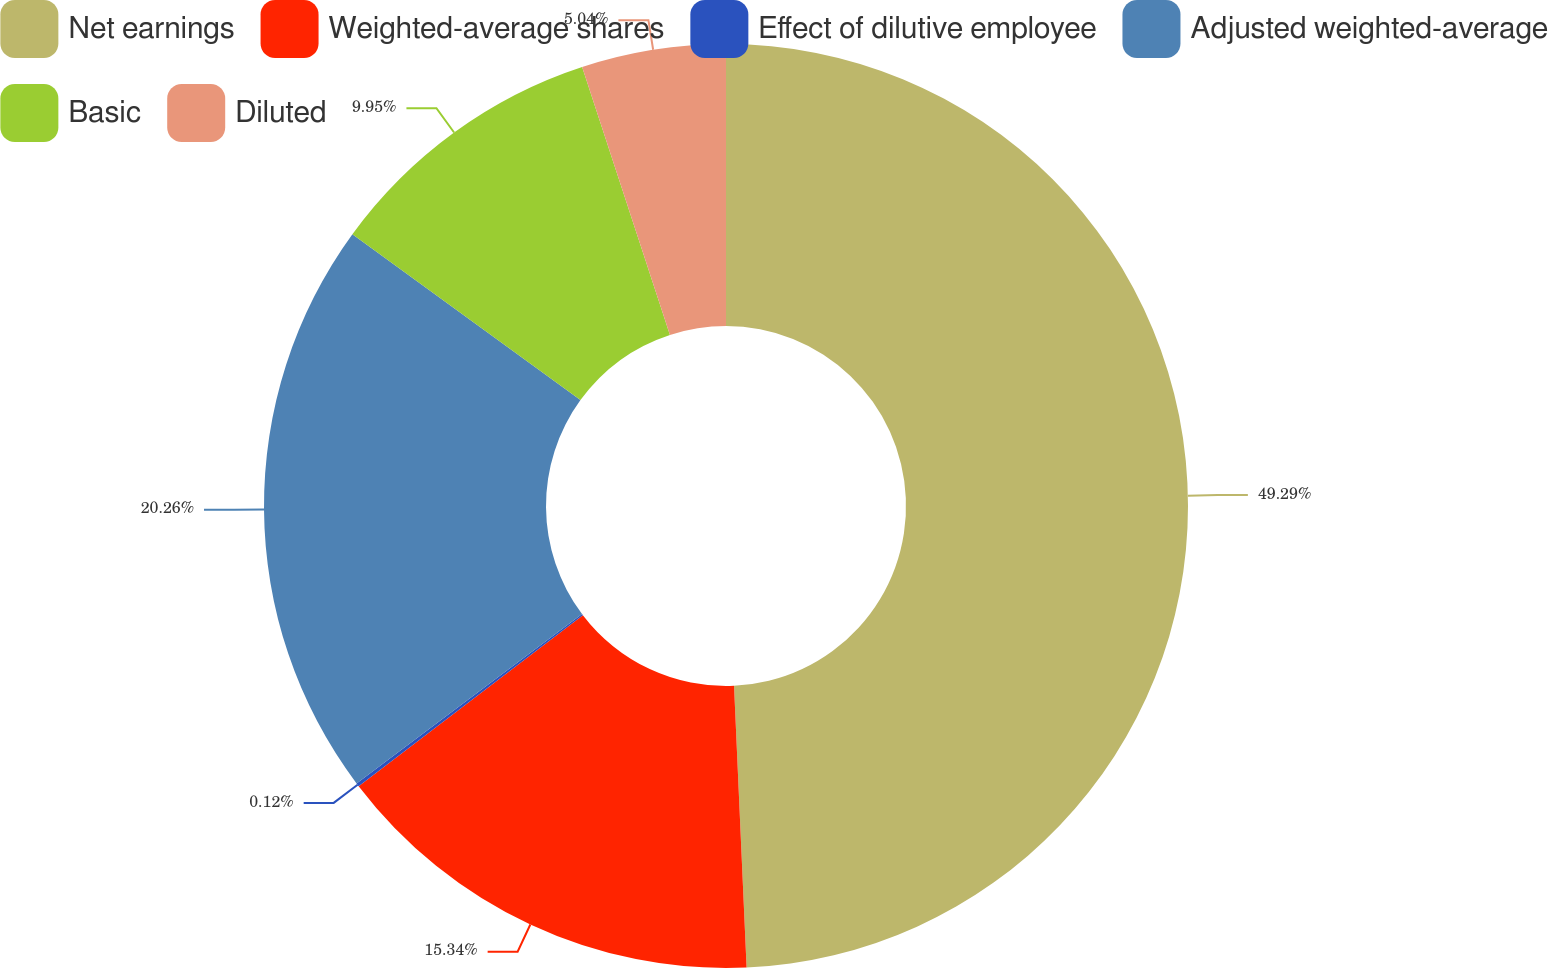<chart> <loc_0><loc_0><loc_500><loc_500><pie_chart><fcel>Net earnings<fcel>Weighted-average shares<fcel>Effect of dilutive employee<fcel>Adjusted weighted-average<fcel>Basic<fcel>Diluted<nl><fcel>49.29%<fcel>15.34%<fcel>0.12%<fcel>20.26%<fcel>9.95%<fcel>5.04%<nl></chart> 